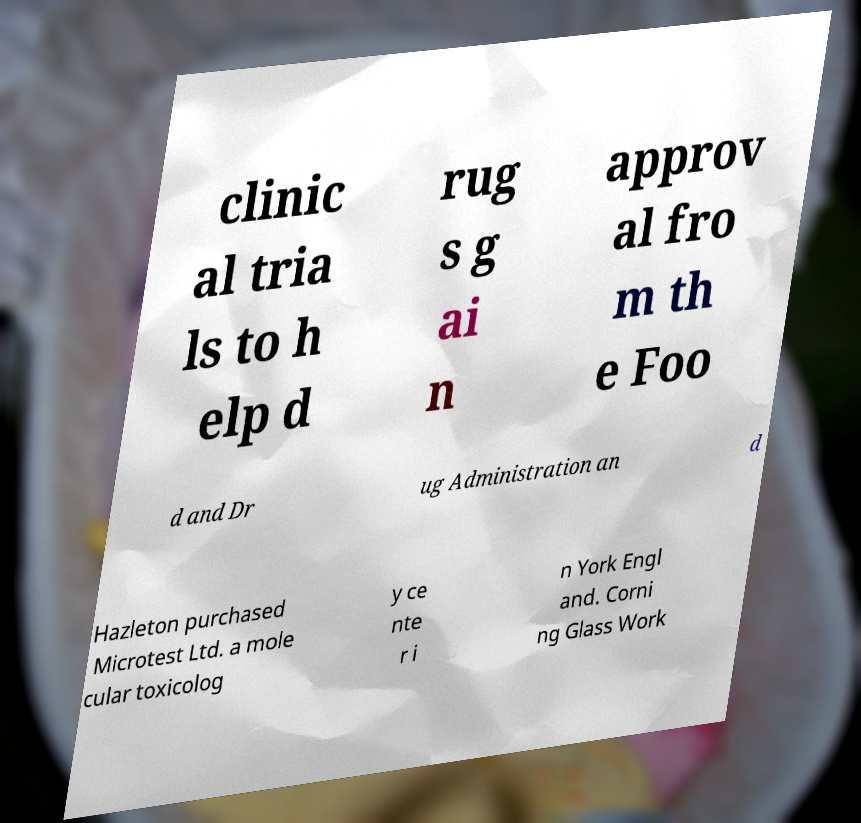What messages or text are displayed in this image? I need them in a readable, typed format. clinic al tria ls to h elp d rug s g ai n approv al fro m th e Foo d and Dr ug Administration an d Hazleton purchased Microtest Ltd. a mole cular toxicolog y ce nte r i n York Engl and. Corni ng Glass Work 